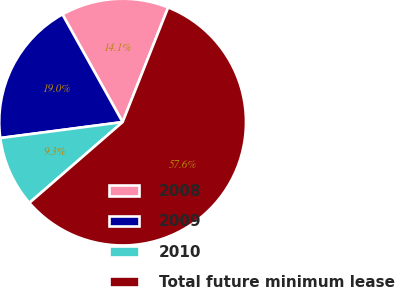Convert chart. <chart><loc_0><loc_0><loc_500><loc_500><pie_chart><fcel>2008<fcel>2009<fcel>2010<fcel>Total future minimum lease<nl><fcel>14.13%<fcel>18.96%<fcel>9.3%<fcel>57.62%<nl></chart> 